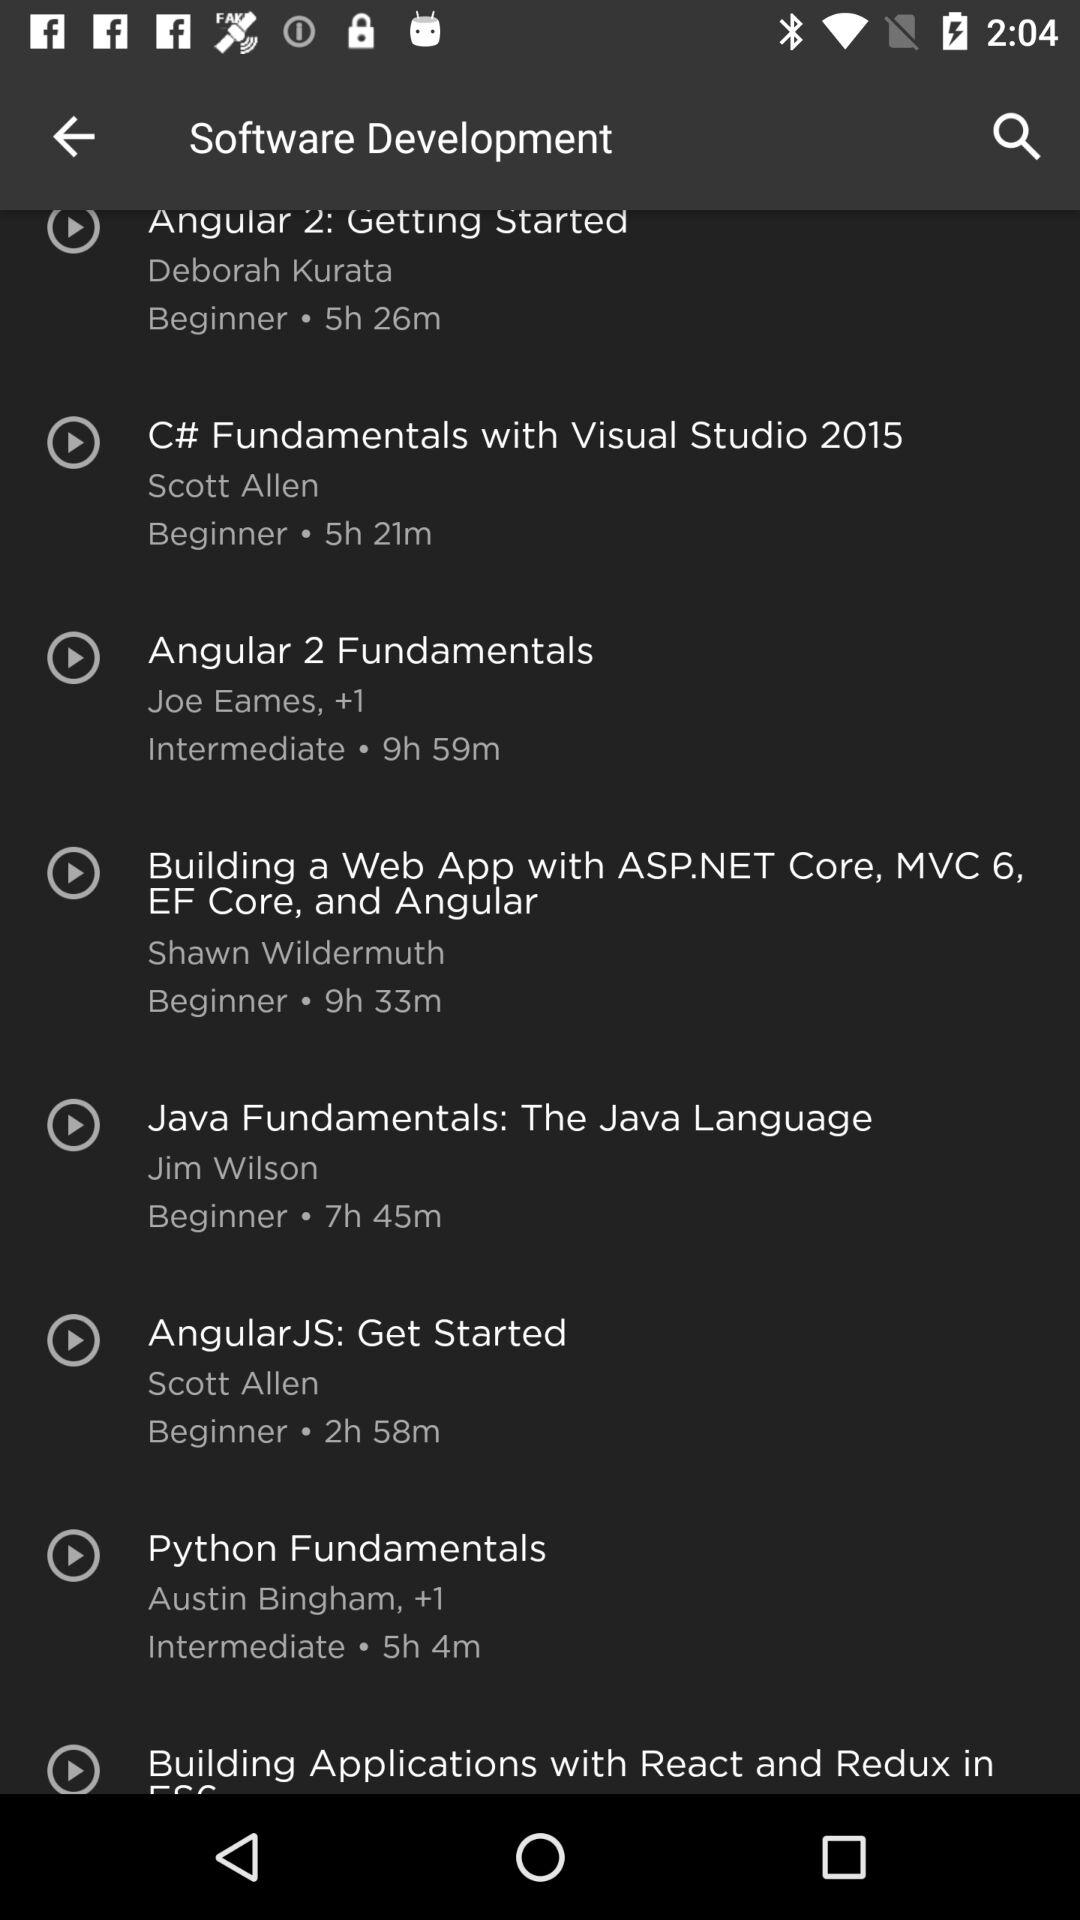What is the duration of the "Angular JS" course? The duration is 2 hours 58 minutes. 